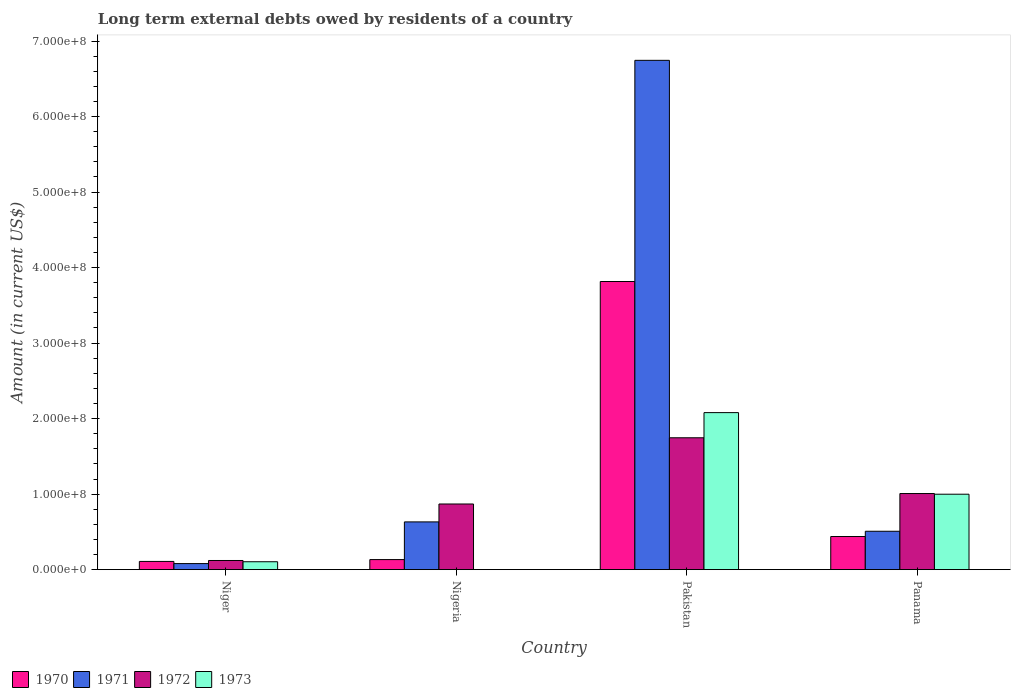Are the number of bars per tick equal to the number of legend labels?
Make the answer very short. No. What is the label of the 4th group of bars from the left?
Offer a very short reply. Panama. In how many cases, is the number of bars for a given country not equal to the number of legend labels?
Keep it short and to the point. 1. What is the amount of long-term external debts owed by residents in 1970 in Pakistan?
Your answer should be compact. 3.82e+08. Across all countries, what is the maximum amount of long-term external debts owed by residents in 1970?
Ensure brevity in your answer.  3.82e+08. Across all countries, what is the minimum amount of long-term external debts owed by residents in 1970?
Your response must be concise. 1.09e+07. What is the total amount of long-term external debts owed by residents in 1971 in the graph?
Make the answer very short. 7.96e+08. What is the difference between the amount of long-term external debts owed by residents in 1970 in Nigeria and that in Pakistan?
Your answer should be very brief. -3.68e+08. What is the difference between the amount of long-term external debts owed by residents in 1973 in Nigeria and the amount of long-term external debts owed by residents in 1972 in Panama?
Your answer should be compact. -1.01e+08. What is the average amount of long-term external debts owed by residents in 1973 per country?
Provide a succinct answer. 7.96e+07. What is the difference between the amount of long-term external debts owed by residents of/in 1973 and amount of long-term external debts owed by residents of/in 1971 in Panama?
Offer a very short reply. 4.90e+07. What is the ratio of the amount of long-term external debts owed by residents in 1973 in Pakistan to that in Panama?
Your response must be concise. 2.08. Is the difference between the amount of long-term external debts owed by residents in 1973 in Niger and Panama greater than the difference between the amount of long-term external debts owed by residents in 1971 in Niger and Panama?
Your answer should be very brief. No. What is the difference between the highest and the second highest amount of long-term external debts owed by residents in 1973?
Provide a succinct answer. 1.97e+08. What is the difference between the highest and the lowest amount of long-term external debts owed by residents in 1970?
Your response must be concise. 3.71e+08. In how many countries, is the amount of long-term external debts owed by residents in 1971 greater than the average amount of long-term external debts owed by residents in 1971 taken over all countries?
Ensure brevity in your answer.  1. Is it the case that in every country, the sum of the amount of long-term external debts owed by residents in 1971 and amount of long-term external debts owed by residents in 1973 is greater than the sum of amount of long-term external debts owed by residents in 1972 and amount of long-term external debts owed by residents in 1970?
Offer a very short reply. No. How many bars are there?
Your answer should be very brief. 15. Are the values on the major ticks of Y-axis written in scientific E-notation?
Your answer should be very brief. Yes. Does the graph contain any zero values?
Offer a terse response. Yes. Does the graph contain grids?
Your answer should be very brief. No. Where does the legend appear in the graph?
Provide a succinct answer. Bottom left. How are the legend labels stacked?
Give a very brief answer. Horizontal. What is the title of the graph?
Keep it short and to the point. Long term external debts owed by residents of a country. What is the label or title of the X-axis?
Offer a very short reply. Country. What is the label or title of the Y-axis?
Offer a very short reply. Amount (in current US$). What is the Amount (in current US$) of 1970 in Niger?
Give a very brief answer. 1.09e+07. What is the Amount (in current US$) of 1971 in Niger?
Provide a short and direct response. 8.00e+06. What is the Amount (in current US$) in 1972 in Niger?
Offer a terse response. 1.21e+07. What is the Amount (in current US$) in 1973 in Niger?
Offer a terse response. 1.04e+07. What is the Amount (in current US$) of 1970 in Nigeria?
Ensure brevity in your answer.  1.33e+07. What is the Amount (in current US$) of 1971 in Nigeria?
Offer a very short reply. 6.32e+07. What is the Amount (in current US$) in 1972 in Nigeria?
Your answer should be compact. 8.69e+07. What is the Amount (in current US$) of 1970 in Pakistan?
Provide a succinct answer. 3.82e+08. What is the Amount (in current US$) in 1971 in Pakistan?
Give a very brief answer. 6.74e+08. What is the Amount (in current US$) of 1972 in Pakistan?
Offer a terse response. 1.75e+08. What is the Amount (in current US$) of 1973 in Pakistan?
Keep it short and to the point. 2.08e+08. What is the Amount (in current US$) in 1970 in Panama?
Make the answer very short. 4.38e+07. What is the Amount (in current US$) in 1971 in Panama?
Ensure brevity in your answer.  5.08e+07. What is the Amount (in current US$) in 1972 in Panama?
Provide a succinct answer. 1.01e+08. What is the Amount (in current US$) in 1973 in Panama?
Your answer should be very brief. 9.99e+07. Across all countries, what is the maximum Amount (in current US$) of 1970?
Ensure brevity in your answer.  3.82e+08. Across all countries, what is the maximum Amount (in current US$) of 1971?
Your answer should be very brief. 6.74e+08. Across all countries, what is the maximum Amount (in current US$) in 1972?
Keep it short and to the point. 1.75e+08. Across all countries, what is the maximum Amount (in current US$) of 1973?
Offer a very short reply. 2.08e+08. Across all countries, what is the minimum Amount (in current US$) of 1970?
Your answer should be compact. 1.09e+07. Across all countries, what is the minimum Amount (in current US$) in 1971?
Your answer should be compact. 8.00e+06. Across all countries, what is the minimum Amount (in current US$) of 1972?
Give a very brief answer. 1.21e+07. Across all countries, what is the minimum Amount (in current US$) in 1973?
Your answer should be very brief. 0. What is the total Amount (in current US$) of 1970 in the graph?
Give a very brief answer. 4.50e+08. What is the total Amount (in current US$) of 1971 in the graph?
Keep it short and to the point. 7.96e+08. What is the total Amount (in current US$) in 1972 in the graph?
Offer a terse response. 3.74e+08. What is the total Amount (in current US$) in 1973 in the graph?
Ensure brevity in your answer.  3.18e+08. What is the difference between the Amount (in current US$) in 1970 in Niger and that in Nigeria?
Your response must be concise. -2.44e+06. What is the difference between the Amount (in current US$) in 1971 in Niger and that in Nigeria?
Make the answer very short. -5.52e+07. What is the difference between the Amount (in current US$) in 1972 in Niger and that in Nigeria?
Provide a short and direct response. -7.48e+07. What is the difference between the Amount (in current US$) of 1970 in Niger and that in Pakistan?
Give a very brief answer. -3.71e+08. What is the difference between the Amount (in current US$) in 1971 in Niger and that in Pakistan?
Your response must be concise. -6.66e+08. What is the difference between the Amount (in current US$) in 1972 in Niger and that in Pakistan?
Give a very brief answer. -1.63e+08. What is the difference between the Amount (in current US$) of 1973 in Niger and that in Pakistan?
Offer a terse response. -1.97e+08. What is the difference between the Amount (in current US$) of 1970 in Niger and that in Panama?
Your answer should be very brief. -3.30e+07. What is the difference between the Amount (in current US$) of 1971 in Niger and that in Panama?
Keep it short and to the point. -4.28e+07. What is the difference between the Amount (in current US$) in 1972 in Niger and that in Panama?
Offer a very short reply. -8.87e+07. What is the difference between the Amount (in current US$) in 1973 in Niger and that in Panama?
Offer a terse response. -8.94e+07. What is the difference between the Amount (in current US$) in 1970 in Nigeria and that in Pakistan?
Make the answer very short. -3.68e+08. What is the difference between the Amount (in current US$) of 1971 in Nigeria and that in Pakistan?
Provide a succinct answer. -6.11e+08. What is the difference between the Amount (in current US$) in 1972 in Nigeria and that in Pakistan?
Keep it short and to the point. -8.77e+07. What is the difference between the Amount (in current US$) of 1970 in Nigeria and that in Panama?
Your response must be concise. -3.05e+07. What is the difference between the Amount (in current US$) of 1971 in Nigeria and that in Panama?
Offer a very short reply. 1.24e+07. What is the difference between the Amount (in current US$) of 1972 in Nigeria and that in Panama?
Your answer should be compact. -1.38e+07. What is the difference between the Amount (in current US$) of 1970 in Pakistan and that in Panama?
Your response must be concise. 3.38e+08. What is the difference between the Amount (in current US$) in 1971 in Pakistan and that in Panama?
Keep it short and to the point. 6.24e+08. What is the difference between the Amount (in current US$) in 1972 in Pakistan and that in Panama?
Ensure brevity in your answer.  7.38e+07. What is the difference between the Amount (in current US$) of 1973 in Pakistan and that in Panama?
Your answer should be very brief. 1.08e+08. What is the difference between the Amount (in current US$) in 1970 in Niger and the Amount (in current US$) in 1971 in Nigeria?
Your answer should be very brief. -5.24e+07. What is the difference between the Amount (in current US$) in 1970 in Niger and the Amount (in current US$) in 1972 in Nigeria?
Make the answer very short. -7.61e+07. What is the difference between the Amount (in current US$) in 1971 in Niger and the Amount (in current US$) in 1972 in Nigeria?
Give a very brief answer. -7.89e+07. What is the difference between the Amount (in current US$) in 1970 in Niger and the Amount (in current US$) in 1971 in Pakistan?
Your response must be concise. -6.64e+08. What is the difference between the Amount (in current US$) in 1970 in Niger and the Amount (in current US$) in 1972 in Pakistan?
Provide a short and direct response. -1.64e+08. What is the difference between the Amount (in current US$) in 1970 in Niger and the Amount (in current US$) in 1973 in Pakistan?
Ensure brevity in your answer.  -1.97e+08. What is the difference between the Amount (in current US$) in 1971 in Niger and the Amount (in current US$) in 1972 in Pakistan?
Offer a terse response. -1.67e+08. What is the difference between the Amount (in current US$) of 1971 in Niger and the Amount (in current US$) of 1973 in Pakistan?
Offer a very short reply. -2.00e+08. What is the difference between the Amount (in current US$) of 1972 in Niger and the Amount (in current US$) of 1973 in Pakistan?
Ensure brevity in your answer.  -1.96e+08. What is the difference between the Amount (in current US$) of 1970 in Niger and the Amount (in current US$) of 1971 in Panama?
Provide a short and direct response. -4.00e+07. What is the difference between the Amount (in current US$) of 1970 in Niger and the Amount (in current US$) of 1972 in Panama?
Provide a short and direct response. -8.99e+07. What is the difference between the Amount (in current US$) in 1970 in Niger and the Amount (in current US$) in 1973 in Panama?
Provide a short and direct response. -8.90e+07. What is the difference between the Amount (in current US$) in 1971 in Niger and the Amount (in current US$) in 1972 in Panama?
Offer a terse response. -9.28e+07. What is the difference between the Amount (in current US$) of 1971 in Niger and the Amount (in current US$) of 1973 in Panama?
Provide a succinct answer. -9.19e+07. What is the difference between the Amount (in current US$) of 1972 in Niger and the Amount (in current US$) of 1973 in Panama?
Your answer should be very brief. -8.78e+07. What is the difference between the Amount (in current US$) of 1970 in Nigeria and the Amount (in current US$) of 1971 in Pakistan?
Make the answer very short. -6.61e+08. What is the difference between the Amount (in current US$) in 1970 in Nigeria and the Amount (in current US$) in 1972 in Pakistan?
Your answer should be compact. -1.61e+08. What is the difference between the Amount (in current US$) in 1970 in Nigeria and the Amount (in current US$) in 1973 in Pakistan?
Give a very brief answer. -1.95e+08. What is the difference between the Amount (in current US$) in 1971 in Nigeria and the Amount (in current US$) in 1972 in Pakistan?
Your answer should be compact. -1.11e+08. What is the difference between the Amount (in current US$) of 1971 in Nigeria and the Amount (in current US$) of 1973 in Pakistan?
Keep it short and to the point. -1.45e+08. What is the difference between the Amount (in current US$) in 1972 in Nigeria and the Amount (in current US$) in 1973 in Pakistan?
Provide a short and direct response. -1.21e+08. What is the difference between the Amount (in current US$) in 1970 in Nigeria and the Amount (in current US$) in 1971 in Panama?
Your answer should be compact. -3.75e+07. What is the difference between the Amount (in current US$) in 1970 in Nigeria and the Amount (in current US$) in 1972 in Panama?
Your answer should be compact. -8.75e+07. What is the difference between the Amount (in current US$) of 1970 in Nigeria and the Amount (in current US$) of 1973 in Panama?
Ensure brevity in your answer.  -8.66e+07. What is the difference between the Amount (in current US$) of 1971 in Nigeria and the Amount (in current US$) of 1972 in Panama?
Ensure brevity in your answer.  -3.76e+07. What is the difference between the Amount (in current US$) of 1971 in Nigeria and the Amount (in current US$) of 1973 in Panama?
Make the answer very short. -3.67e+07. What is the difference between the Amount (in current US$) in 1972 in Nigeria and the Amount (in current US$) in 1973 in Panama?
Ensure brevity in your answer.  -1.29e+07. What is the difference between the Amount (in current US$) of 1970 in Pakistan and the Amount (in current US$) of 1971 in Panama?
Offer a very short reply. 3.31e+08. What is the difference between the Amount (in current US$) in 1970 in Pakistan and the Amount (in current US$) in 1972 in Panama?
Your answer should be compact. 2.81e+08. What is the difference between the Amount (in current US$) of 1970 in Pakistan and the Amount (in current US$) of 1973 in Panama?
Offer a very short reply. 2.82e+08. What is the difference between the Amount (in current US$) of 1971 in Pakistan and the Amount (in current US$) of 1972 in Panama?
Make the answer very short. 5.74e+08. What is the difference between the Amount (in current US$) in 1971 in Pakistan and the Amount (in current US$) in 1973 in Panama?
Offer a very short reply. 5.75e+08. What is the difference between the Amount (in current US$) of 1972 in Pakistan and the Amount (in current US$) of 1973 in Panama?
Provide a succinct answer. 7.47e+07. What is the average Amount (in current US$) in 1970 per country?
Provide a short and direct response. 1.12e+08. What is the average Amount (in current US$) of 1971 per country?
Provide a succinct answer. 1.99e+08. What is the average Amount (in current US$) of 1972 per country?
Give a very brief answer. 9.36e+07. What is the average Amount (in current US$) in 1973 per country?
Ensure brevity in your answer.  7.96e+07. What is the difference between the Amount (in current US$) in 1970 and Amount (in current US$) in 1971 in Niger?
Offer a very short reply. 2.86e+06. What is the difference between the Amount (in current US$) of 1970 and Amount (in current US$) of 1972 in Niger?
Provide a succinct answer. -1.23e+06. What is the difference between the Amount (in current US$) in 1970 and Amount (in current US$) in 1973 in Niger?
Your answer should be very brief. 4.08e+05. What is the difference between the Amount (in current US$) of 1971 and Amount (in current US$) of 1972 in Niger?
Provide a succinct answer. -4.09e+06. What is the difference between the Amount (in current US$) of 1971 and Amount (in current US$) of 1973 in Niger?
Your answer should be compact. -2.45e+06. What is the difference between the Amount (in current US$) of 1972 and Amount (in current US$) of 1973 in Niger?
Offer a terse response. 1.64e+06. What is the difference between the Amount (in current US$) of 1970 and Amount (in current US$) of 1971 in Nigeria?
Give a very brief answer. -4.99e+07. What is the difference between the Amount (in current US$) in 1970 and Amount (in current US$) in 1972 in Nigeria?
Offer a terse response. -7.36e+07. What is the difference between the Amount (in current US$) in 1971 and Amount (in current US$) in 1972 in Nigeria?
Your answer should be compact. -2.37e+07. What is the difference between the Amount (in current US$) in 1970 and Amount (in current US$) in 1971 in Pakistan?
Make the answer very short. -2.93e+08. What is the difference between the Amount (in current US$) in 1970 and Amount (in current US$) in 1972 in Pakistan?
Your answer should be very brief. 2.07e+08. What is the difference between the Amount (in current US$) in 1970 and Amount (in current US$) in 1973 in Pakistan?
Provide a short and direct response. 1.74e+08. What is the difference between the Amount (in current US$) of 1971 and Amount (in current US$) of 1972 in Pakistan?
Make the answer very short. 5.00e+08. What is the difference between the Amount (in current US$) of 1971 and Amount (in current US$) of 1973 in Pakistan?
Provide a short and direct response. 4.67e+08. What is the difference between the Amount (in current US$) in 1972 and Amount (in current US$) in 1973 in Pakistan?
Provide a short and direct response. -3.33e+07. What is the difference between the Amount (in current US$) in 1970 and Amount (in current US$) in 1971 in Panama?
Your response must be concise. -6.98e+06. What is the difference between the Amount (in current US$) in 1970 and Amount (in current US$) in 1972 in Panama?
Offer a terse response. -5.69e+07. What is the difference between the Amount (in current US$) in 1970 and Amount (in current US$) in 1973 in Panama?
Provide a succinct answer. -5.60e+07. What is the difference between the Amount (in current US$) in 1971 and Amount (in current US$) in 1972 in Panama?
Keep it short and to the point. -5.00e+07. What is the difference between the Amount (in current US$) in 1971 and Amount (in current US$) in 1973 in Panama?
Provide a short and direct response. -4.90e+07. What is the difference between the Amount (in current US$) of 1972 and Amount (in current US$) of 1973 in Panama?
Ensure brevity in your answer.  9.03e+05. What is the ratio of the Amount (in current US$) of 1970 in Niger to that in Nigeria?
Offer a very short reply. 0.82. What is the ratio of the Amount (in current US$) of 1971 in Niger to that in Nigeria?
Provide a short and direct response. 0.13. What is the ratio of the Amount (in current US$) of 1972 in Niger to that in Nigeria?
Give a very brief answer. 0.14. What is the ratio of the Amount (in current US$) in 1970 in Niger to that in Pakistan?
Provide a short and direct response. 0.03. What is the ratio of the Amount (in current US$) in 1971 in Niger to that in Pakistan?
Keep it short and to the point. 0.01. What is the ratio of the Amount (in current US$) of 1972 in Niger to that in Pakistan?
Ensure brevity in your answer.  0.07. What is the ratio of the Amount (in current US$) of 1973 in Niger to that in Pakistan?
Provide a short and direct response. 0.05. What is the ratio of the Amount (in current US$) in 1970 in Niger to that in Panama?
Your answer should be very brief. 0.25. What is the ratio of the Amount (in current US$) of 1971 in Niger to that in Panama?
Your response must be concise. 0.16. What is the ratio of the Amount (in current US$) in 1972 in Niger to that in Panama?
Offer a terse response. 0.12. What is the ratio of the Amount (in current US$) in 1973 in Niger to that in Panama?
Make the answer very short. 0.1. What is the ratio of the Amount (in current US$) in 1970 in Nigeria to that in Pakistan?
Offer a terse response. 0.03. What is the ratio of the Amount (in current US$) in 1971 in Nigeria to that in Pakistan?
Provide a succinct answer. 0.09. What is the ratio of the Amount (in current US$) of 1972 in Nigeria to that in Pakistan?
Your answer should be very brief. 0.5. What is the ratio of the Amount (in current US$) in 1970 in Nigeria to that in Panama?
Your answer should be compact. 0.3. What is the ratio of the Amount (in current US$) of 1971 in Nigeria to that in Panama?
Offer a terse response. 1.24. What is the ratio of the Amount (in current US$) of 1972 in Nigeria to that in Panama?
Offer a terse response. 0.86. What is the ratio of the Amount (in current US$) of 1970 in Pakistan to that in Panama?
Offer a very short reply. 8.7. What is the ratio of the Amount (in current US$) of 1971 in Pakistan to that in Panama?
Keep it short and to the point. 13.27. What is the ratio of the Amount (in current US$) in 1972 in Pakistan to that in Panama?
Your answer should be compact. 1.73. What is the ratio of the Amount (in current US$) in 1973 in Pakistan to that in Panama?
Your answer should be compact. 2.08. What is the difference between the highest and the second highest Amount (in current US$) in 1970?
Your answer should be compact. 3.38e+08. What is the difference between the highest and the second highest Amount (in current US$) of 1971?
Provide a succinct answer. 6.11e+08. What is the difference between the highest and the second highest Amount (in current US$) of 1972?
Your response must be concise. 7.38e+07. What is the difference between the highest and the second highest Amount (in current US$) of 1973?
Ensure brevity in your answer.  1.08e+08. What is the difference between the highest and the lowest Amount (in current US$) in 1970?
Provide a succinct answer. 3.71e+08. What is the difference between the highest and the lowest Amount (in current US$) in 1971?
Your answer should be very brief. 6.66e+08. What is the difference between the highest and the lowest Amount (in current US$) of 1972?
Your response must be concise. 1.63e+08. What is the difference between the highest and the lowest Amount (in current US$) in 1973?
Ensure brevity in your answer.  2.08e+08. 